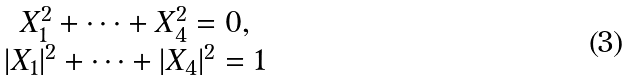Convert formula to latex. <formula><loc_0><loc_0><loc_500><loc_500>\begin{array} { c } { { X _ { 1 } ^ { 2 } + \dots + X _ { 4 } ^ { 2 } = 0 , } } \\ { { | X _ { 1 } | ^ { 2 } + \dots + | X _ { 4 } | ^ { 2 } = 1 } } \end{array}</formula> 